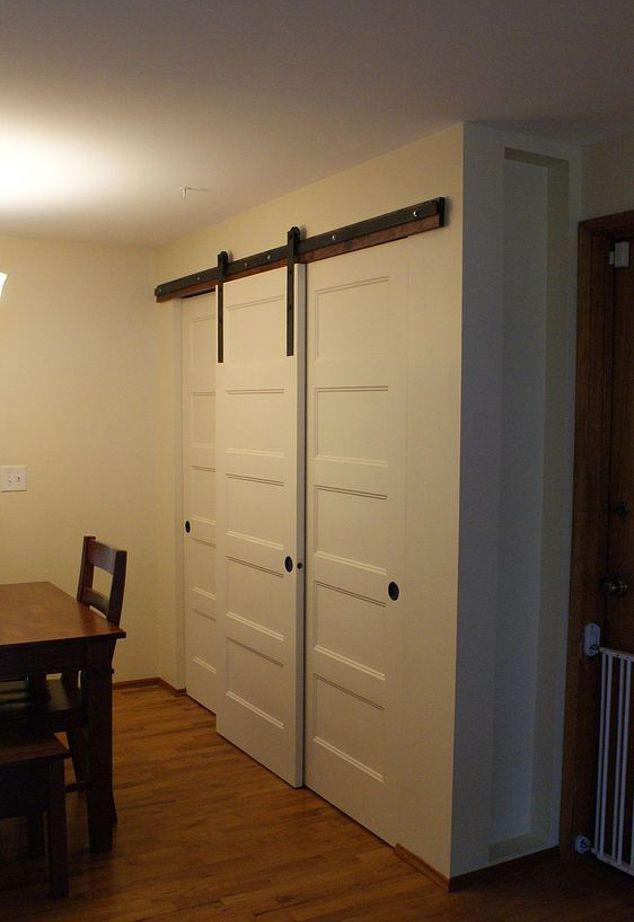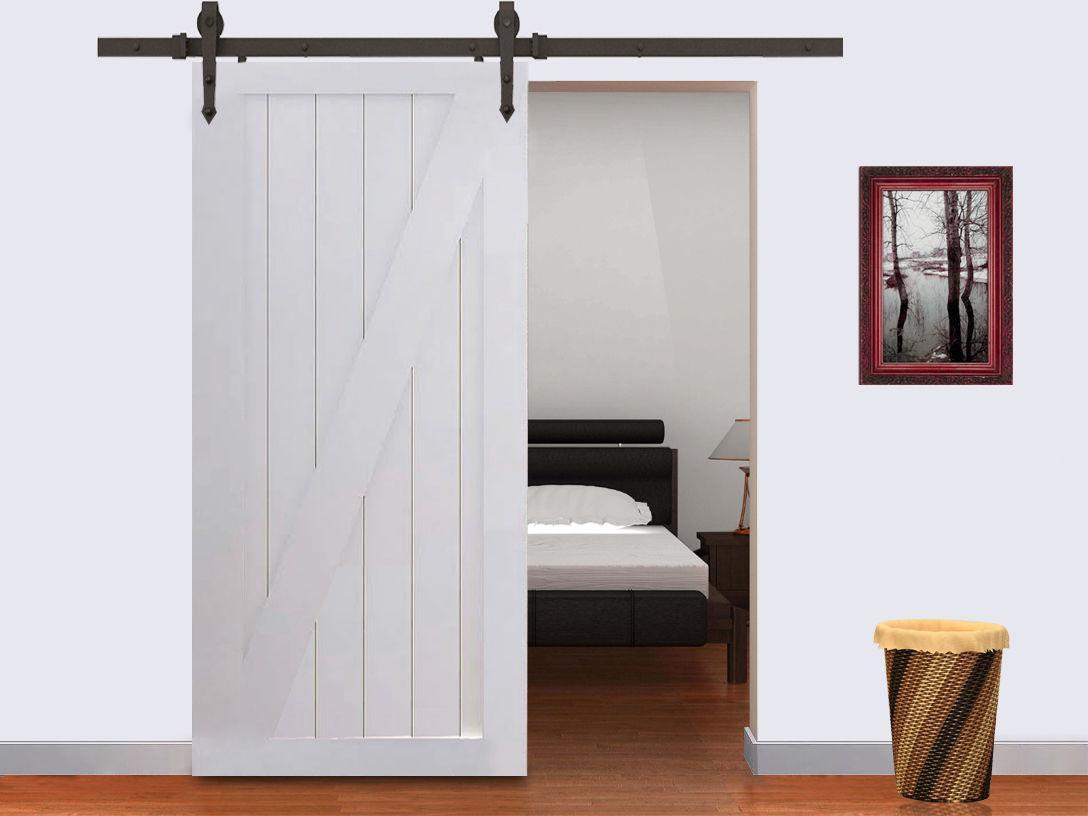The first image is the image on the left, the second image is the image on the right. Analyze the images presented: Is the assertion "There are multiple doors in one image." valid? Answer yes or no. Yes. The first image is the image on the left, the second image is the image on the right. Evaluate the accuracy of this statement regarding the images: "The left and right image contains the same number of hanging doors with at least one white wooden door.". Is it true? Answer yes or no. Yes. 